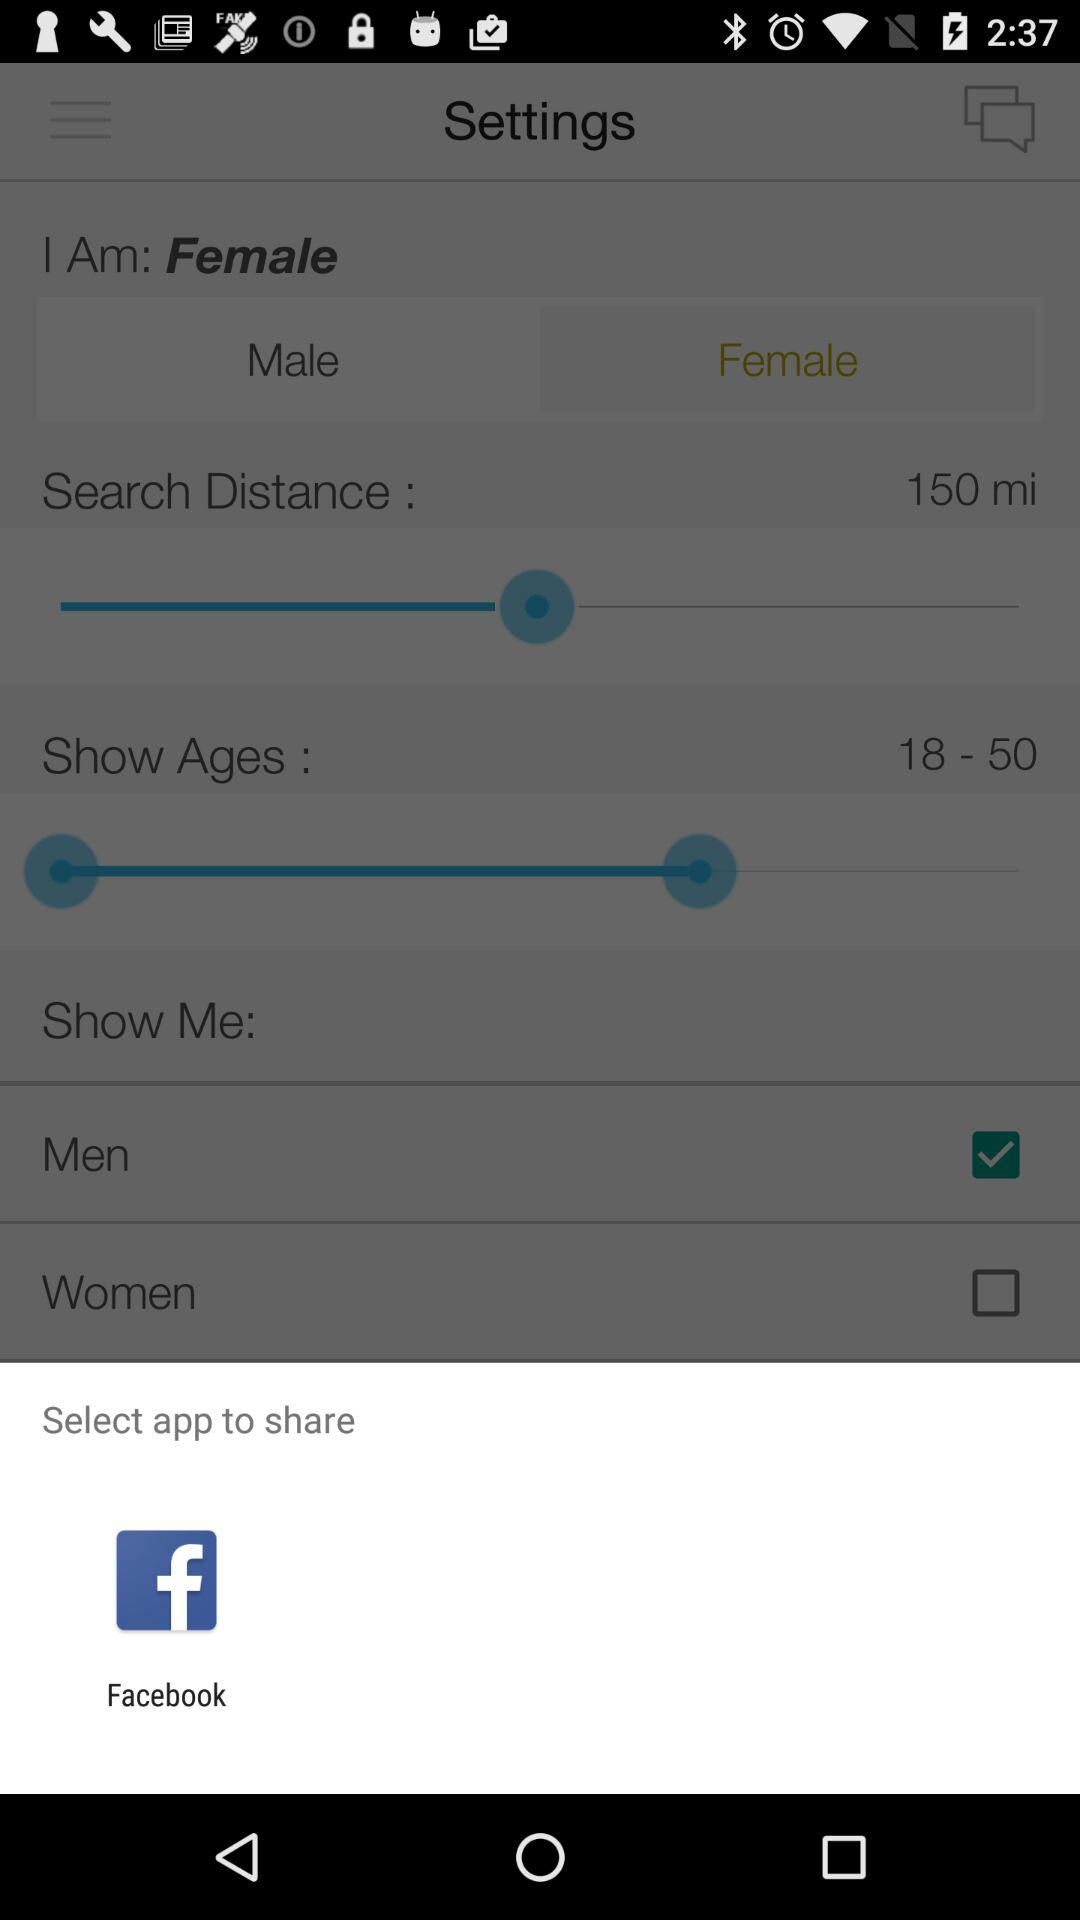What application should I choose to share? You should use "Facebook". 